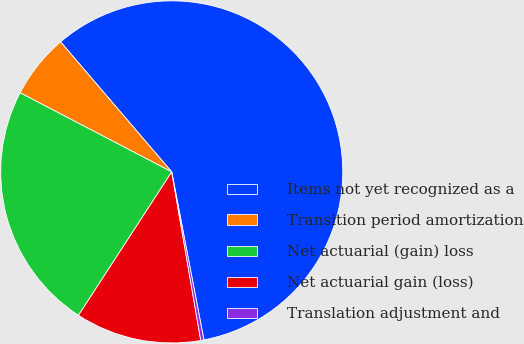Convert chart. <chart><loc_0><loc_0><loc_500><loc_500><pie_chart><fcel>Items not yet recognized as a<fcel>Transition period amortization<fcel>Net actuarial (gain) loss<fcel>Net actuarial gain (loss)<fcel>Translation adjustment and<nl><fcel>58.25%<fcel>6.09%<fcel>23.48%<fcel>11.89%<fcel>0.3%<nl></chart> 